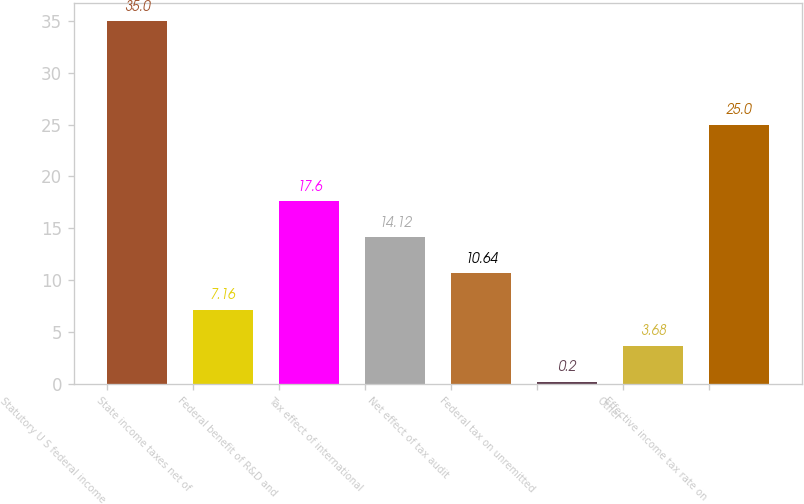Convert chart to OTSL. <chart><loc_0><loc_0><loc_500><loc_500><bar_chart><fcel>Statutory U S federal income<fcel>State income taxes net of<fcel>Federal benefit of R&D and<fcel>Tax effect of international<fcel>Net effect of tax audit<fcel>Federal tax on unremitted<fcel>Other<fcel>Effective income tax rate on<nl><fcel>35<fcel>7.16<fcel>17.6<fcel>14.12<fcel>10.64<fcel>0.2<fcel>3.68<fcel>25<nl></chart> 